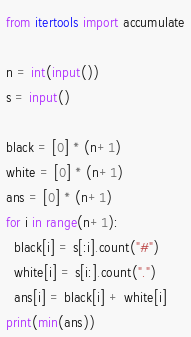Convert code to text. <code><loc_0><loc_0><loc_500><loc_500><_Python_>from itertools import accumulate

n = int(input())
s = input()

black = [0] * (n+1)
white = [0] * (n+1)
ans = [0] * (n+1)
for i in range(n+1):
  black[i] = s[:i].count("#")
  white[i] = s[i:].count(".")
  ans[i] = black[i] + white[i]
print(min(ans))</code> 